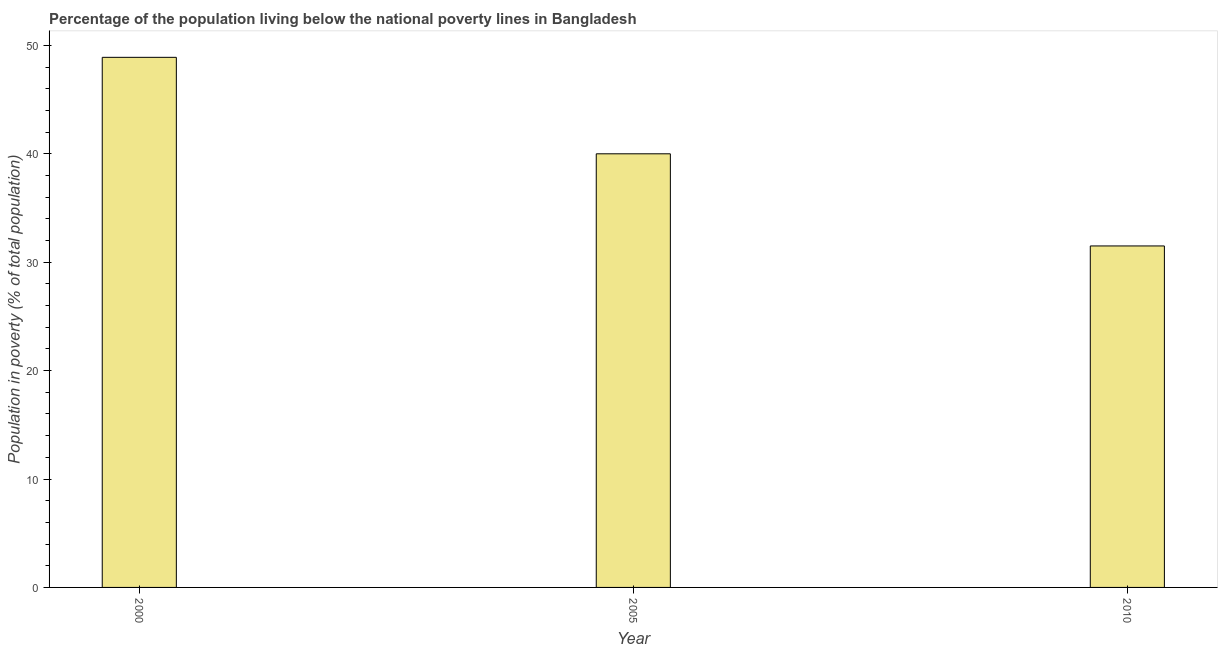What is the title of the graph?
Offer a very short reply. Percentage of the population living below the national poverty lines in Bangladesh. What is the label or title of the Y-axis?
Provide a succinct answer. Population in poverty (% of total population). What is the percentage of population living below poverty line in 2010?
Offer a very short reply. 31.5. Across all years, what is the maximum percentage of population living below poverty line?
Offer a terse response. 48.9. Across all years, what is the minimum percentage of population living below poverty line?
Your answer should be compact. 31.5. What is the sum of the percentage of population living below poverty line?
Ensure brevity in your answer.  120.4. What is the average percentage of population living below poverty line per year?
Your answer should be very brief. 40.13. What is the median percentage of population living below poverty line?
Ensure brevity in your answer.  40. In how many years, is the percentage of population living below poverty line greater than 14 %?
Offer a terse response. 3. Do a majority of the years between 2000 and 2005 (inclusive) have percentage of population living below poverty line greater than 24 %?
Provide a short and direct response. Yes. What is the ratio of the percentage of population living below poverty line in 2000 to that in 2005?
Ensure brevity in your answer.  1.22. Is the percentage of population living below poverty line in 2000 less than that in 2005?
Your answer should be compact. No. Is the difference between the percentage of population living below poverty line in 2000 and 2010 greater than the difference between any two years?
Make the answer very short. Yes. Is the sum of the percentage of population living below poverty line in 2005 and 2010 greater than the maximum percentage of population living below poverty line across all years?
Give a very brief answer. Yes. What is the difference between the highest and the lowest percentage of population living below poverty line?
Ensure brevity in your answer.  17.4. What is the Population in poverty (% of total population) of 2000?
Ensure brevity in your answer.  48.9. What is the Population in poverty (% of total population) of 2005?
Keep it short and to the point. 40. What is the Population in poverty (% of total population) in 2010?
Offer a terse response. 31.5. What is the difference between the Population in poverty (% of total population) in 2000 and 2005?
Make the answer very short. 8.9. What is the difference between the Population in poverty (% of total population) in 2005 and 2010?
Your answer should be very brief. 8.5. What is the ratio of the Population in poverty (% of total population) in 2000 to that in 2005?
Provide a succinct answer. 1.22. What is the ratio of the Population in poverty (% of total population) in 2000 to that in 2010?
Provide a succinct answer. 1.55. What is the ratio of the Population in poverty (% of total population) in 2005 to that in 2010?
Your answer should be very brief. 1.27. 